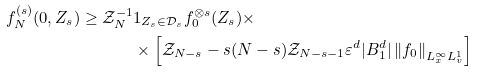<formula> <loc_0><loc_0><loc_500><loc_500>f _ { N } ^ { ( s ) } ( 0 , Z _ { s } ) \geq \mathcal { Z } _ { N } ^ { - 1 } & 1 _ { Z _ { s } \in \mathcal { D } _ { s } } f _ { 0 } ^ { \otimes s } ( Z _ { s } ) \times \\ & \times \left [ \mathcal { Z } _ { N - s } - s ( N - s ) \mathcal { Z } _ { N - s - 1 } \varepsilon ^ { d } | B _ { 1 } ^ { d } | \left \| f _ { 0 } \right \| _ { L ^ { \infty } _ { x } L ^ { 1 } _ { v } } \right ]</formula> 